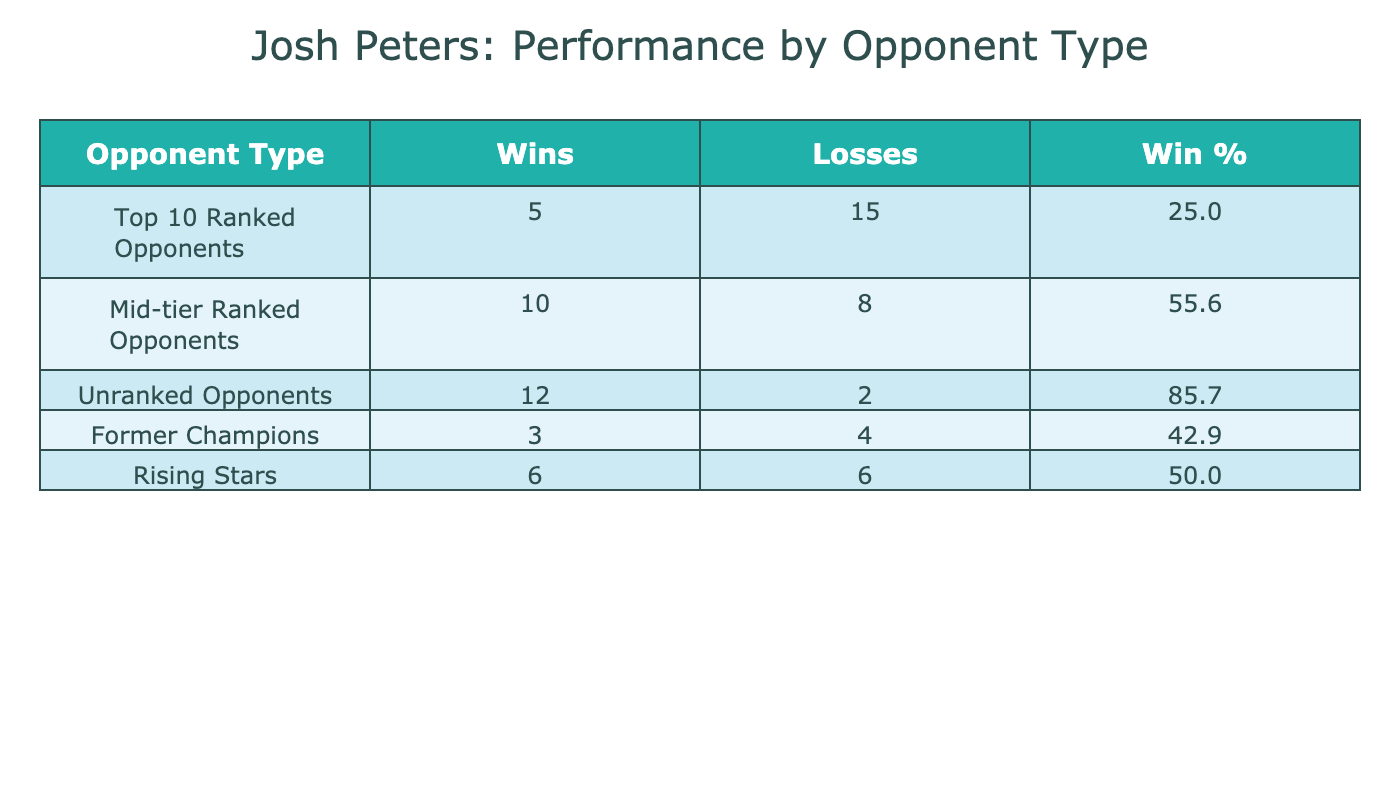What is the win percentage against Top 10 Ranked Opponents? To calculate the win percentage, we take the number of wins (5) and divide it by the total number of matches (5 wins + 15 losses = 20 matches). Therefore, the win percentage is (5 / 20) * 100 = 25.0%.
Answer: 25.0% How many wins did Josh Peters achieve against Mid-tier Ranked Opponents? According to the table, he has achieved 10 wins against Mid-tier Ranked Opponents.
Answer: 10 What is the total number of matches Josh Peters has fought against Unranked Opponents? For Unranked Opponents, the total matches are the sum of wins (12) and losses (2), which is 12 + 2 = 14 matches.
Answer: 14 Did Josh Peters win more matches against Rising Stars than he lost? He won 6 matches and lost 6 matches against Rising Stars, so he did not win more than he lost, as both numbers are equal.
Answer: No What is the difference in total matches fought between Top 10 Ranked Opponents and Former Champions? Total matches against Top 10 Ranked Opponents = 20 (5 wins + 15 losses), and against Former Champions = 7 (3 wins + 4 losses). The difference is 20 - 7 = 13 matches.
Answer: 13 Which opponent type has the highest win percentage? To determine the highest win percentage, we calculate the win percentage for each opponent type. For Unranked Opponents, it is (12 / 14) * 100 = 85.7%. Mid-tier Ranked Opponents is (10 / 18) * 100 = 55.6%. Top 10 Ranked Opponents is (5 / 20) * 100 = 25.0%. Former Champions is (3 / 7) * 100 = 42.9%. Rising Stars is (6 / 12) * 100 = 50.0%. The highest win percentage is for Unranked Opponents at 85.7%.
Answer: Unranked Opponents How many total losses did he have against all opponent types? To find the total losses, we sum the losses across all opponent types: 15 (Top 10) + 8 (Mid-tier) + 2 (Unranked) + 4 (Former Champions) + 6 (Rising Stars) = 35 total losses.
Answer: 35 Is the win percentage against Former Champions higher than against Mid-tier Ranked Opponents? The win percentage against Former Champions is (3 / 7) * 100 = 42.9% and against Mid-tier Ranked Opponents is (10 / 18) * 100 = 55.6%. Since 42.9% is less than 55.6%, the statement is false.
Answer: No What is the average win percentage across all opponent types? First, we calculate the win percentages for each opponent type: Top 10 = 25.0%, Mid-tier = 55.6%, Unranked = 85.7%, Former Champions = 42.9%, Rising Stars = 50.0%. The total of these percentages is 25.0 + 55.6 + 85.7 + 42.9 + 50.0 = 259.2. Then we divide by the number of opponent types (5) to find the average: 259.2 / 5 = 51.84%.
Answer: 51.84% 